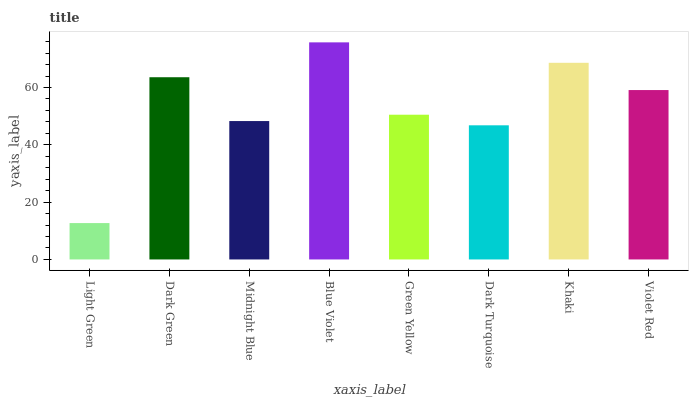Is Light Green the minimum?
Answer yes or no. Yes. Is Blue Violet the maximum?
Answer yes or no. Yes. Is Dark Green the minimum?
Answer yes or no. No. Is Dark Green the maximum?
Answer yes or no. No. Is Dark Green greater than Light Green?
Answer yes or no. Yes. Is Light Green less than Dark Green?
Answer yes or no. Yes. Is Light Green greater than Dark Green?
Answer yes or no. No. Is Dark Green less than Light Green?
Answer yes or no. No. Is Violet Red the high median?
Answer yes or no. Yes. Is Green Yellow the low median?
Answer yes or no. Yes. Is Green Yellow the high median?
Answer yes or no. No. Is Dark Turquoise the low median?
Answer yes or no. No. 